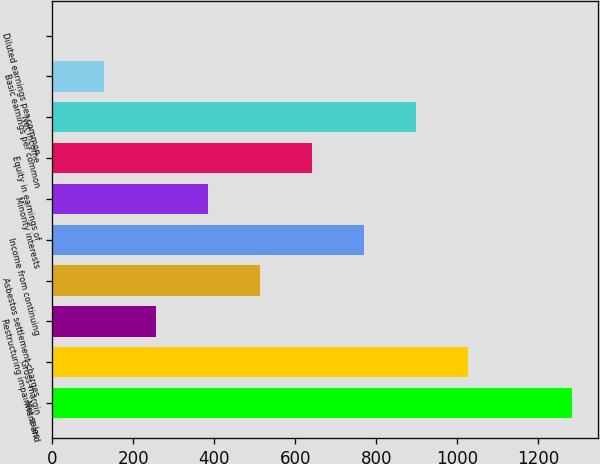Convert chart to OTSL. <chart><loc_0><loc_0><loc_500><loc_500><bar_chart><fcel>Net sales<fcel>Gross margin<fcel>Restructuring impairment and<fcel>Asbestos settlement charges<fcel>Income from continuing<fcel>Minority interests<fcel>Equity in earnings of<fcel>Net income<fcel>Basic earnings per common<fcel>Diluted earnings per common<nl><fcel>1282<fcel>1025.63<fcel>256.61<fcel>512.95<fcel>769.29<fcel>384.78<fcel>641.12<fcel>897.46<fcel>128.44<fcel>0.27<nl></chart> 